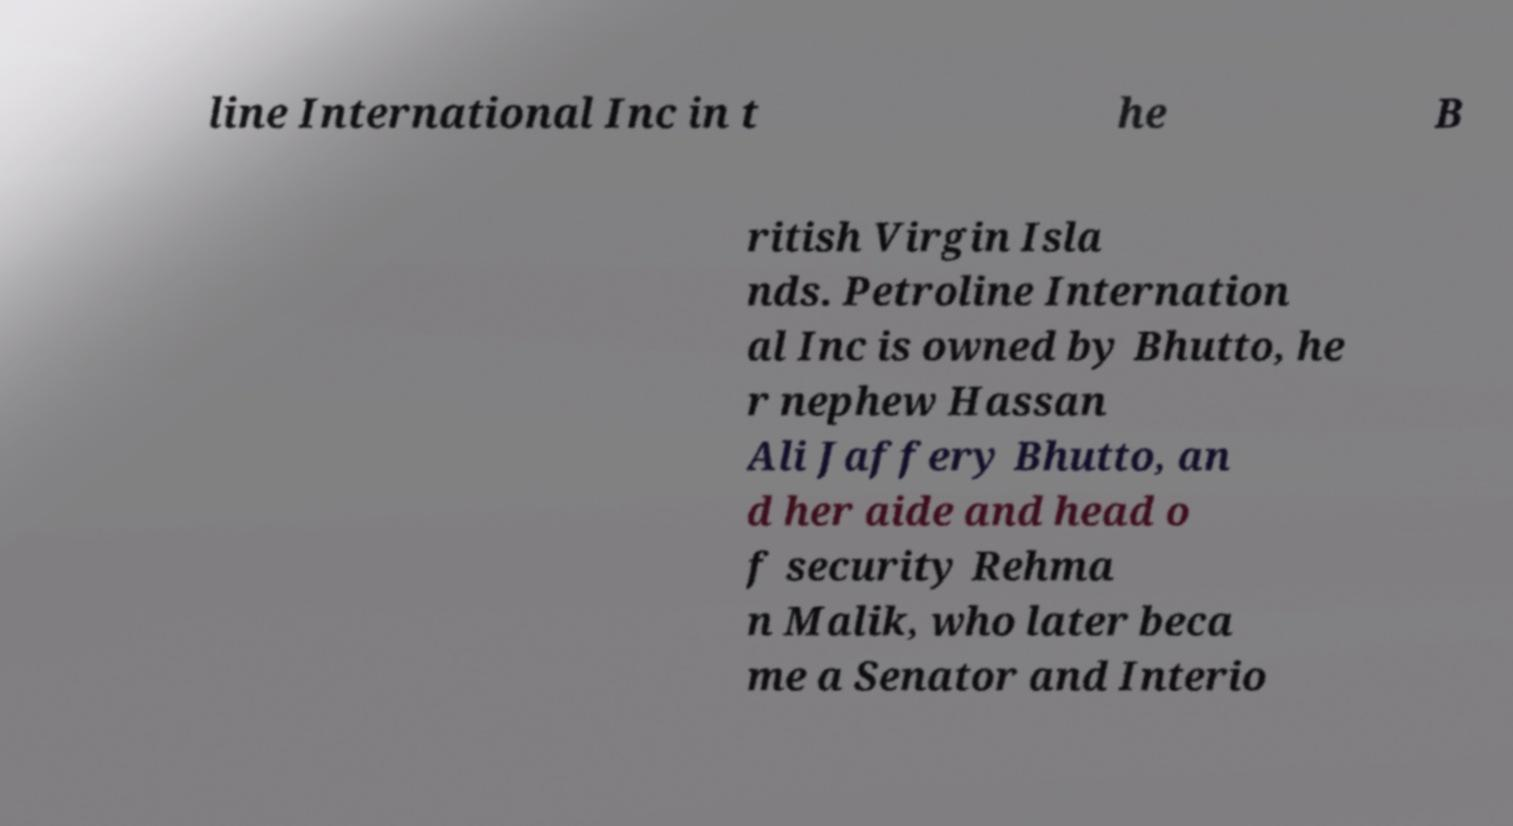Can you accurately transcribe the text from the provided image for me? line International Inc in t he B ritish Virgin Isla nds. Petroline Internation al Inc is owned by Bhutto, he r nephew Hassan Ali Jaffery Bhutto, an d her aide and head o f security Rehma n Malik, who later beca me a Senator and Interio 